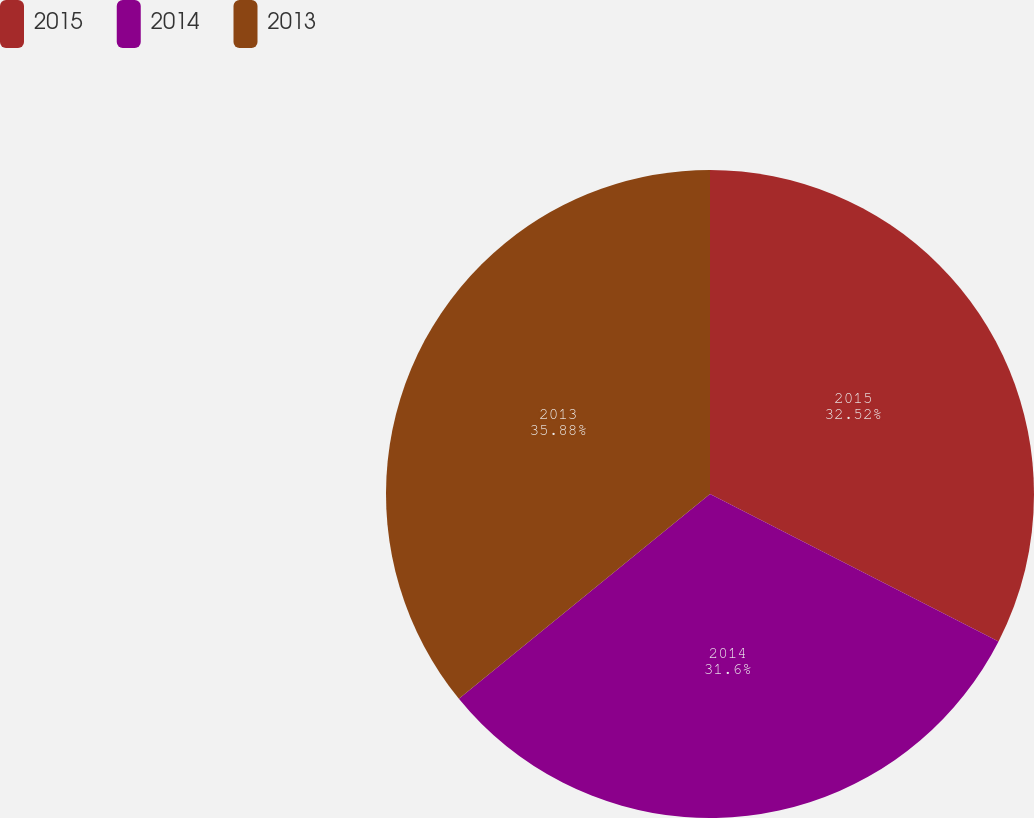Convert chart. <chart><loc_0><loc_0><loc_500><loc_500><pie_chart><fcel>2015<fcel>2014<fcel>2013<nl><fcel>32.52%<fcel>31.6%<fcel>35.89%<nl></chart> 